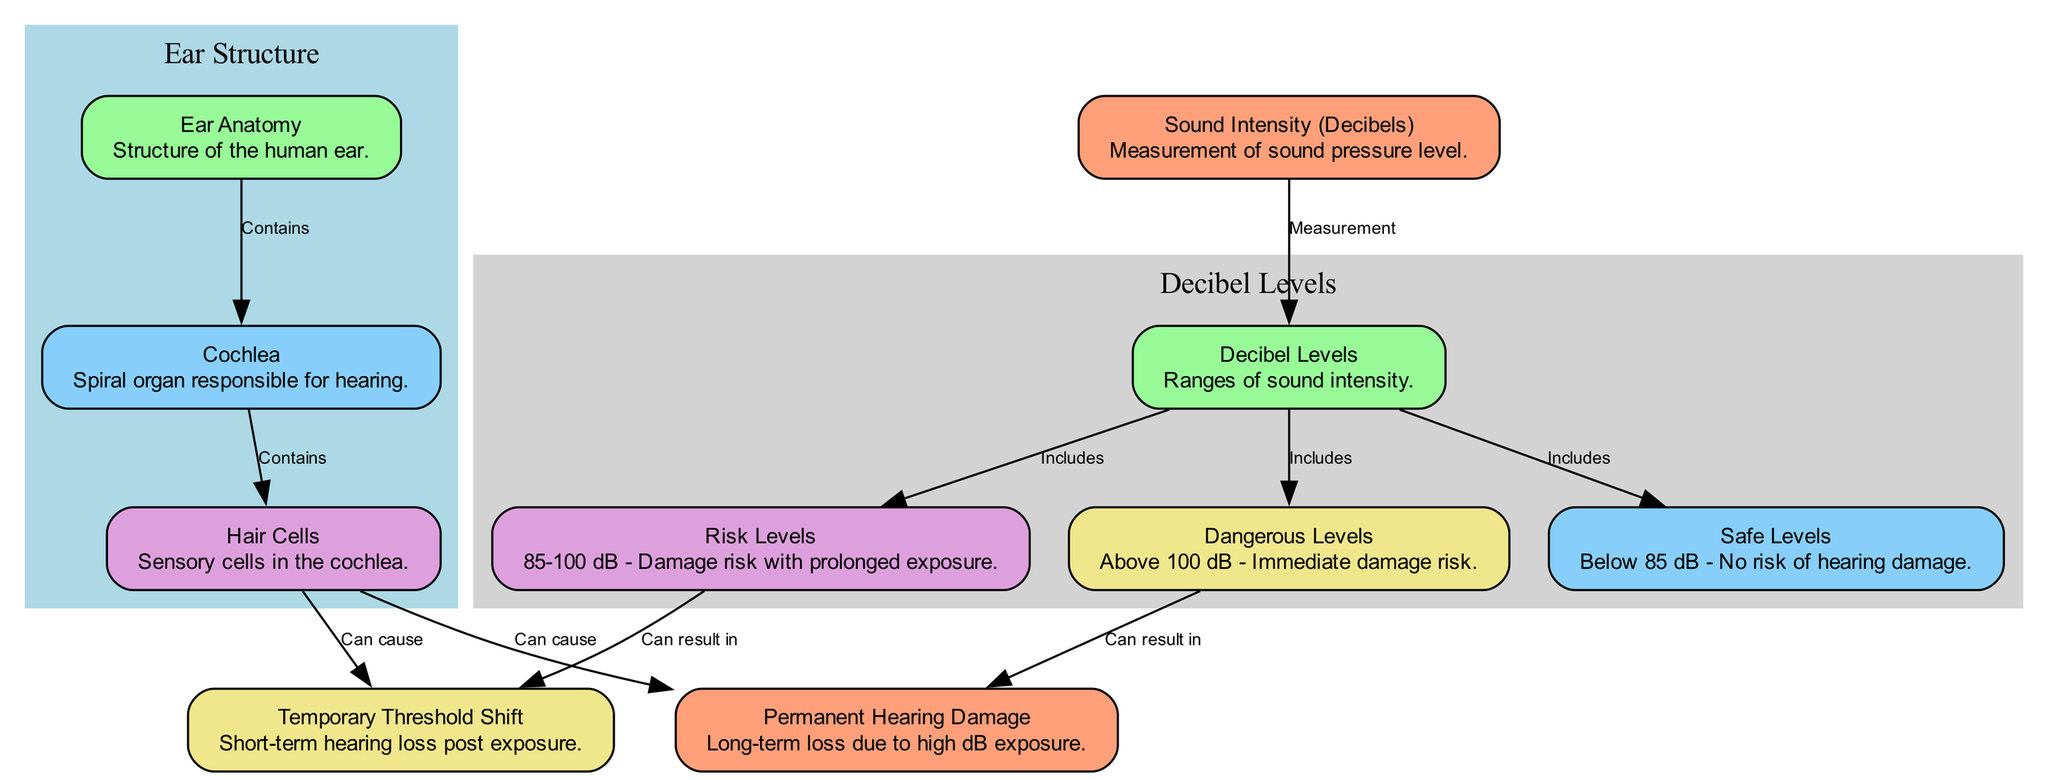What's the measurement of sound intensity shown in the diagram? The diagram specifies that sound intensity is measured in decibels, which is indicated in the node labeled "Sound Intensity (Decibels)."
Answer: decibels What is the safe level for sound intensity? The safe level for sound intensity is explicitly mentioned in the node labeled "Safe Levels," stating that it is below 85 dB.
Answer: below 85 dB How many decibel level categories are depicted in the diagram? The diagram shows four categories of decibel levels: Safe Levels, Risk Levels, and Dangerous Levels, thus a total of three categories is noted.
Answer: three What can result from exposure to risk levels (85-100 dB)? According to the edges leading from the "Risk Levels" node, exposure in this category can result in a "Temporary Threshold Shift."
Answer: Temporary Threshold Shift Which sensory cells in the cochlea are susceptible to damage from loud music? The diagram links "Hair Cells" to the potential outcomes of hearing loss, so hair cells in the cochlea are the ones that can be damaged.
Answer: Hair Cells What immediate damage risk is associated with sound levels above 100 dB? The diagram states that sound levels above 100 dB can result in "Permanent Hearing Damage," as indicated in the edges relating to "Dangerous Levels."
Answer: Permanent Hearing Damage How do hair cells affect hearing loss? The "Hair Cells" node indicates that they can cause both "Temporary Threshold Shift" and "Permanent Hearing Damage," linking their condition directly with hearing loss issues.
Answer: Temporary Threshold Shift and Permanent Hearing Damage What is the relationship between cochlea and ear anatomy? The diagram details a connection where the "Ear Anatomy" node contains the "Cochlea," indicating that cochlea is part of the ear structure, which supports its function for hearing.
Answer: Contains What risk is indicated at sound levels between 85-100 dB? The diagram states that the risk level at sound levels between 85-100 dB is that it can result in "Temporary Threshold Shift," showing a direct relationship between the level of sound and potential hearing issues.
Answer: Temporary Threshold Shift 